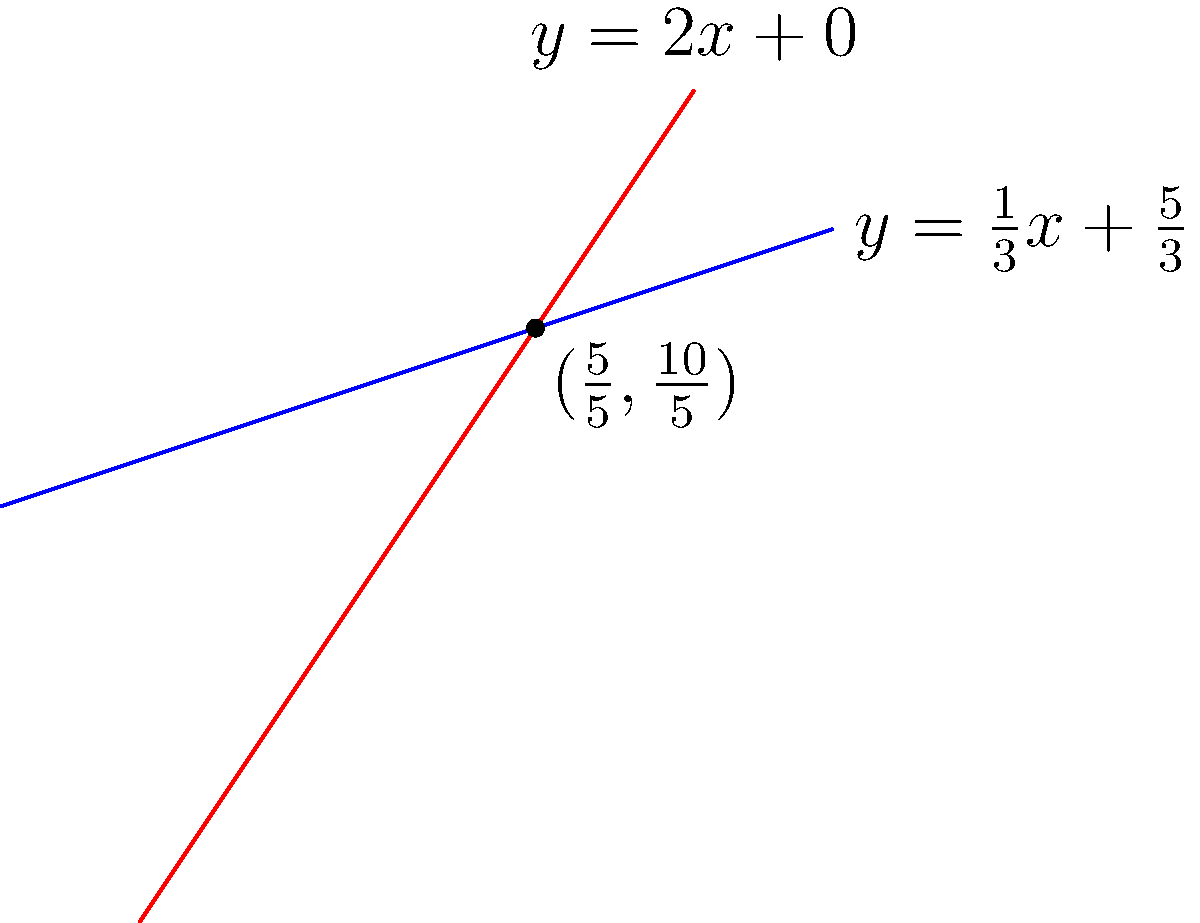As a senior .NET developer working on a geometry-based application, you need to implement a function that determines the intersection point of two lines given their equations. Consider the following two lines:

Line 1: $y = \frac{1}{3}x + \frac{5}{3}$
Line 2: $y = 2x + 0$

What is the intersection point of these two lines? Express your answer as a pair of coordinates $(x, y)$. To find the intersection point of two lines, we need to solve the system of equations:

$$\begin{cases}
y = \frac{1}{3}x + \frac{5}{3} \\
y = 2x + 0
\end{cases}$$

Step 1: Set the equations equal to each other:
$$\frac{1}{3}x + \frac{5}{3} = 2x + 0$$

Step 2: Subtract $\frac{1}{3}x$ from both sides:
$$\frac{5}{3} = \frac{5}{3}x + 0$$

Step 3: Subtract $\frac{5}{3}$ from both sides:
$$0 = \frac{5}{3}x - \frac{5}{3}$$

Step 4: Add $\frac{5}{3}$ to both sides:
$$\frac{5}{3} = \frac{5}{3}x$$

Step 5: Divide both sides by $\frac{5}{3}$:
$$1 = x$$

So, $x = 1$

Step 6: Substitute $x = 1$ into either of the original equations. Let's use the first one:
$$y = \frac{1}{3}(1) + \frac{5}{3} = \frac{1}{3} + \frac{5}{3} = \frac{6}{3} = 2$$

Therefore, the intersection point is $(1, 2)$.
Answer: $(1, 2)$ 